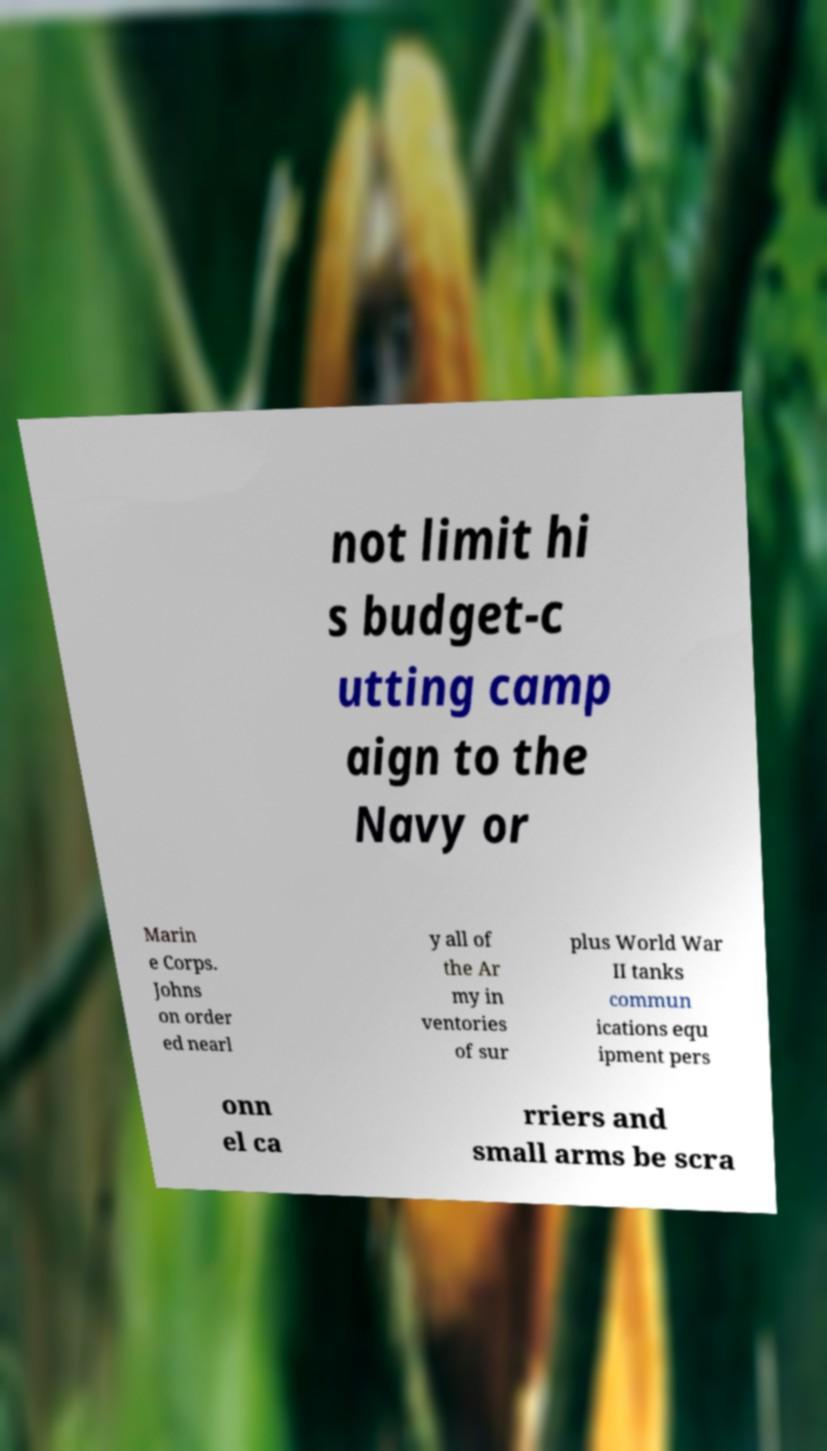What messages or text are displayed in this image? I need them in a readable, typed format. not limit hi s budget-c utting camp aign to the Navy or Marin e Corps. Johns on order ed nearl y all of the Ar my in ventories of sur plus World War II tanks commun ications equ ipment pers onn el ca rriers and small arms be scra 